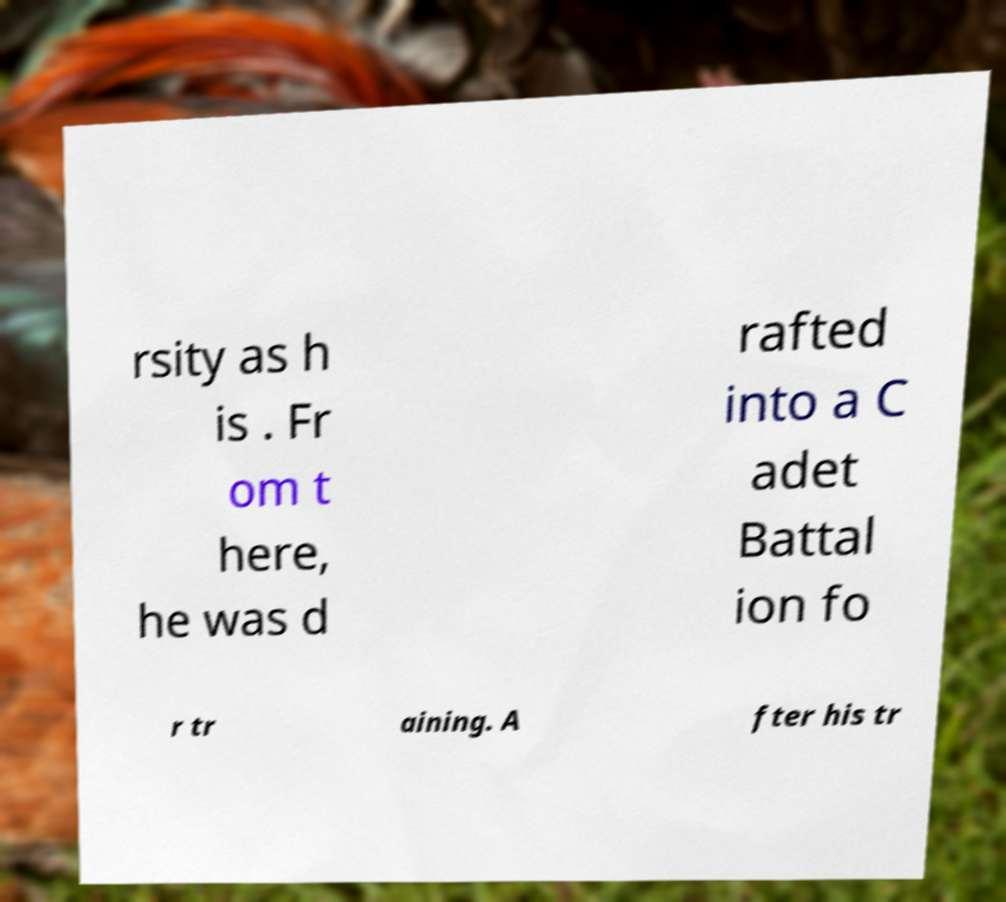I need the written content from this picture converted into text. Can you do that? rsity as h is . Fr om t here, he was d rafted into a C adet Battal ion fo r tr aining. A fter his tr 